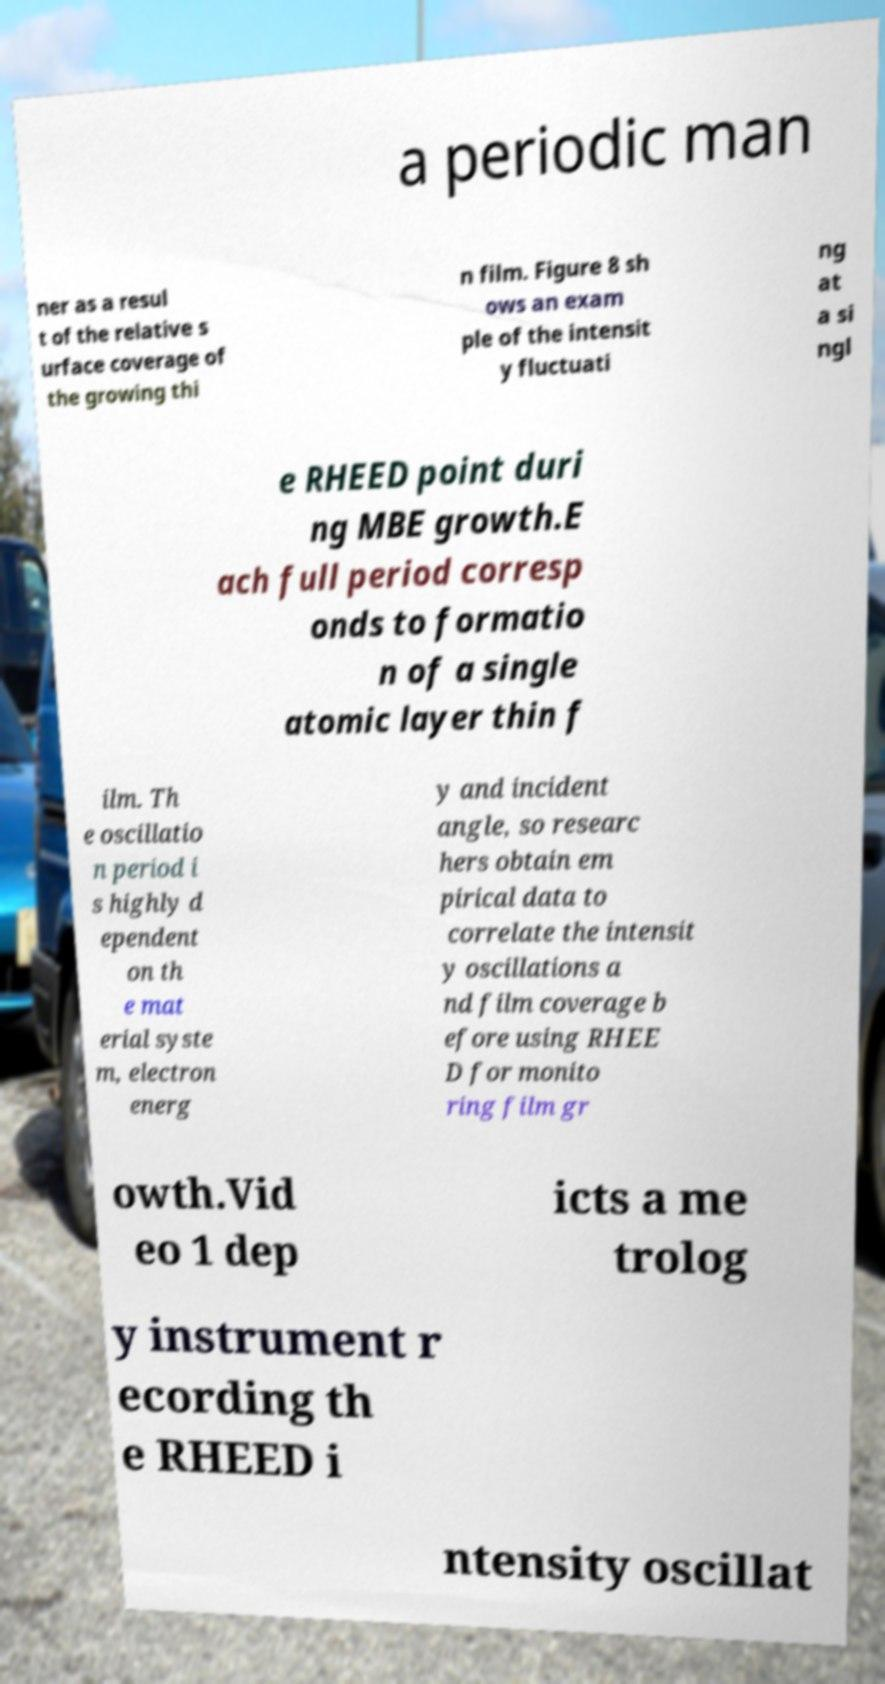What messages or text are displayed in this image? I need them in a readable, typed format. a periodic man ner as a resul t of the relative s urface coverage of the growing thi n film. Figure 8 sh ows an exam ple of the intensit y fluctuati ng at a si ngl e RHEED point duri ng MBE growth.E ach full period corresp onds to formatio n of a single atomic layer thin f ilm. Th e oscillatio n period i s highly d ependent on th e mat erial syste m, electron energ y and incident angle, so researc hers obtain em pirical data to correlate the intensit y oscillations a nd film coverage b efore using RHEE D for monito ring film gr owth.Vid eo 1 dep icts a me trolog y instrument r ecording th e RHEED i ntensity oscillat 